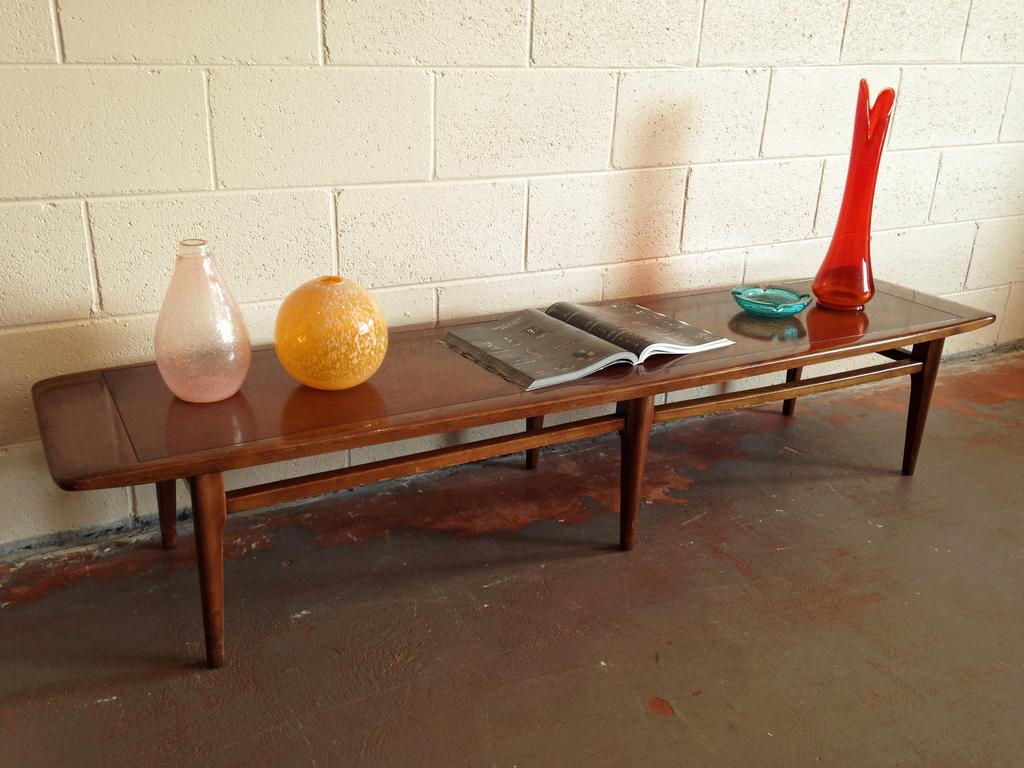What type of furniture is in the image? There is a bench in the image. What objects are placed on the bench? Glass items and a book are present on the bench. What can be seen in the background of the image? There is a well in the background of the image. What is visible at the bottom of the image? The floor is visible at the bottom of the image. Can you see a snake slithering on the bench in the image? No, there is no snake present in the image. 